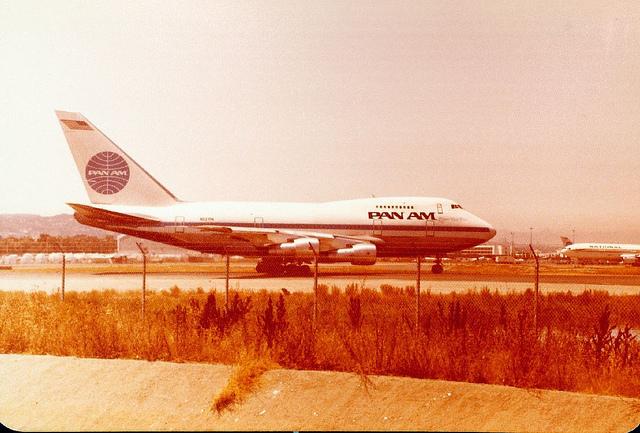What airline does this plane belong to?
Quick response, please. Pan am. Is this a recent photograph?
Quick response, please. No. Is it flying?
Quick response, please. No. Is the plane on the runway?
Be succinct. Yes. 